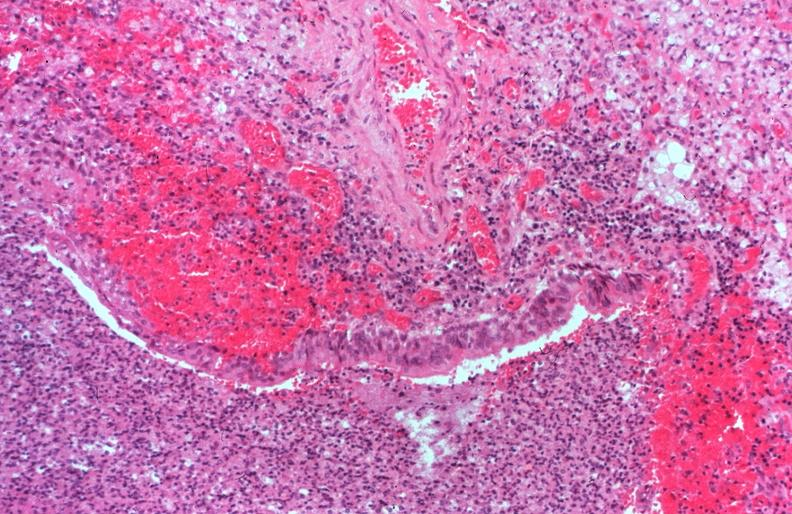where is this?
Answer the question using a single word or phrase. Lung 